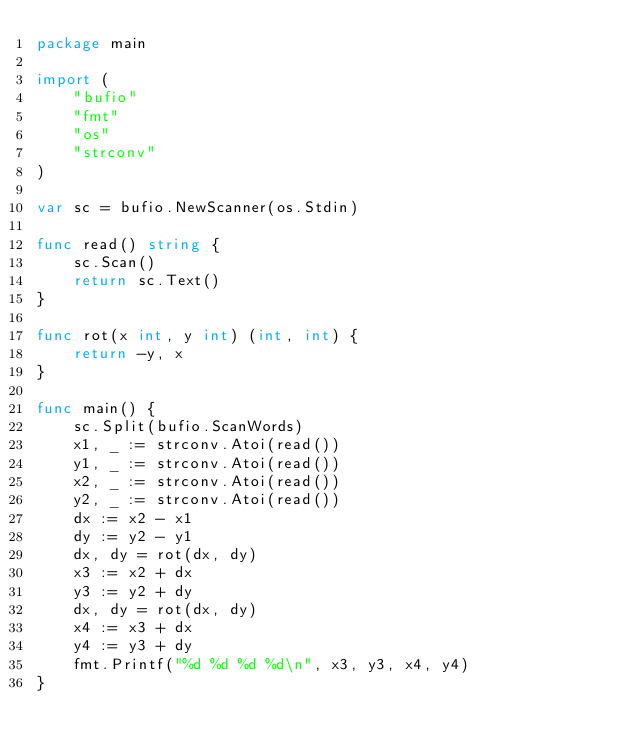Convert code to text. <code><loc_0><loc_0><loc_500><loc_500><_Go_>package main

import (
	"bufio"
	"fmt"
	"os"
	"strconv"
)

var sc = bufio.NewScanner(os.Stdin)

func read() string {
	sc.Scan()
	return sc.Text()
}

func rot(x int, y int) (int, int) {
	return -y, x
}

func main() {
	sc.Split(bufio.ScanWords)
	x1, _ := strconv.Atoi(read())
	y1, _ := strconv.Atoi(read())
	x2, _ := strconv.Atoi(read())
	y2, _ := strconv.Atoi(read())
	dx := x2 - x1
	dy := y2 - y1
	dx, dy = rot(dx, dy)
	x3 := x2 + dx
	y3 := y2 + dy
	dx, dy = rot(dx, dy)
	x4 := x3 + dx
	y4 := y3 + dy
	fmt.Printf("%d %d %d %d\n", x3, y3, x4, y4)
}
</code> 